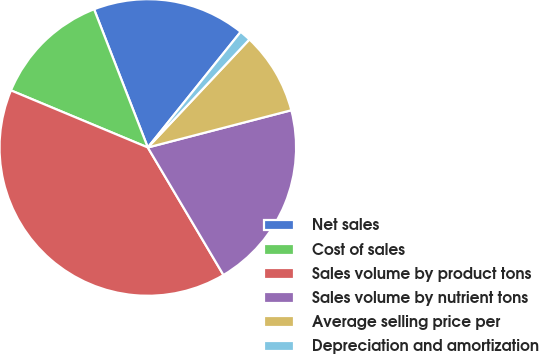<chart> <loc_0><loc_0><loc_500><loc_500><pie_chart><fcel>Net sales<fcel>Cost of sales<fcel>Sales volume by product tons<fcel>Sales volume by nutrient tons<fcel>Average selling price per<fcel>Depreciation and amortization<nl><fcel>16.67%<fcel>12.81%<fcel>39.81%<fcel>20.52%<fcel>8.95%<fcel>1.24%<nl></chart> 